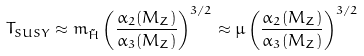<formula> <loc_0><loc_0><loc_500><loc_500>T _ { S U S Y } \approx m _ { \tilde { H } } \left ( \frac { \alpha _ { 2 } ( M _ { Z } ) } { \alpha _ { 3 } ( M _ { Z } ) } \right ) ^ { 3 / 2 } \approx \mu \left ( \frac { \alpha _ { 2 } ( M _ { Z } ) } { \alpha _ { 3 } ( M _ { Z } ) } \right ) ^ { 3 / 2 }</formula> 